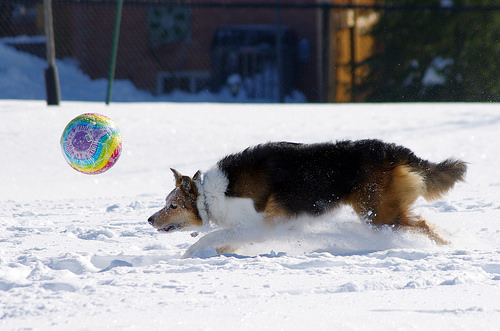<image>
Is the ball behind the dog? No. The ball is not behind the dog. From this viewpoint, the ball appears to be positioned elsewhere in the scene. Where is the dog in relation to the ball? Is it to the right of the ball? Yes. From this viewpoint, the dog is positioned to the right side relative to the ball. Where is the dog in relation to the ball? Is it in front of the ball? No. The dog is not in front of the ball. The spatial positioning shows a different relationship between these objects. 